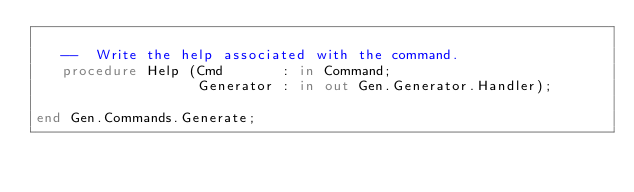Convert code to text. <code><loc_0><loc_0><loc_500><loc_500><_Ada_>
   --  Write the help associated with the command.
   procedure Help (Cmd       : in Command;
                   Generator : in out Gen.Generator.Handler);

end Gen.Commands.Generate;
</code> 